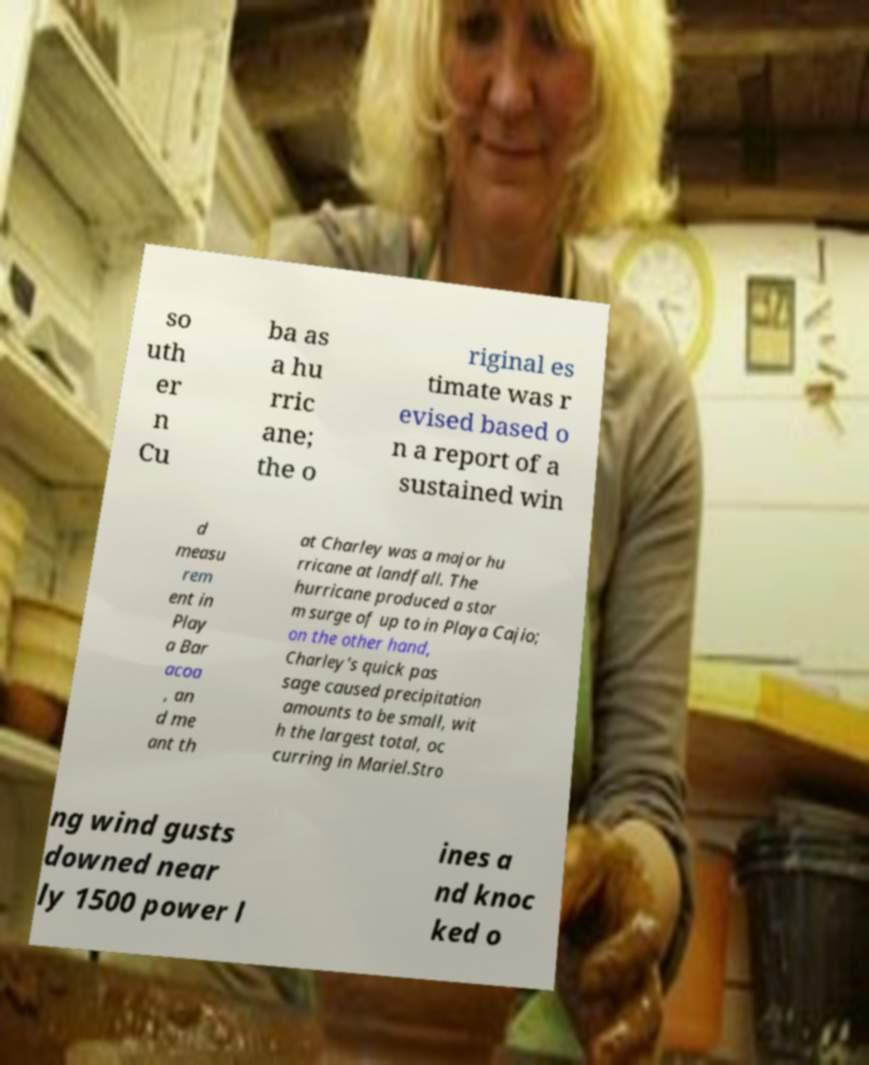Could you assist in decoding the text presented in this image and type it out clearly? so uth er n Cu ba as a hu rric ane; the o riginal es timate was r evised based o n a report of a sustained win d measu rem ent in Play a Bar acoa , an d me ant th at Charley was a major hu rricane at landfall. The hurricane produced a stor m surge of up to in Playa Cajio; on the other hand, Charley's quick pas sage caused precipitation amounts to be small, wit h the largest total, oc curring in Mariel.Stro ng wind gusts downed near ly 1500 power l ines a nd knoc ked o 